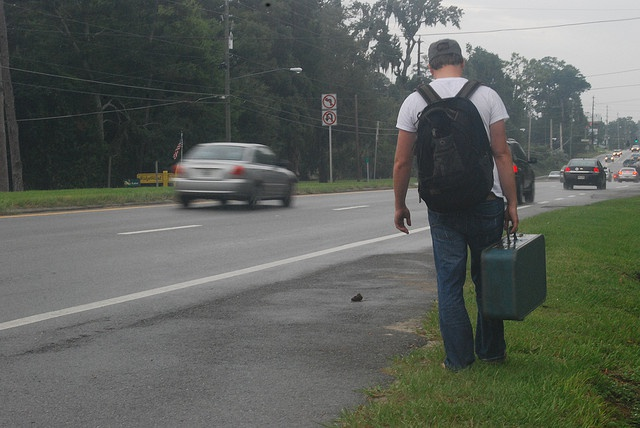Describe the objects in this image and their specific colors. I can see people in black, gray, darkgray, and darkblue tones, backpack in black and gray tones, car in black, gray, darkgray, and purple tones, suitcase in black, purple, gray, and darkgray tones, and car in black, gray, and purple tones in this image. 